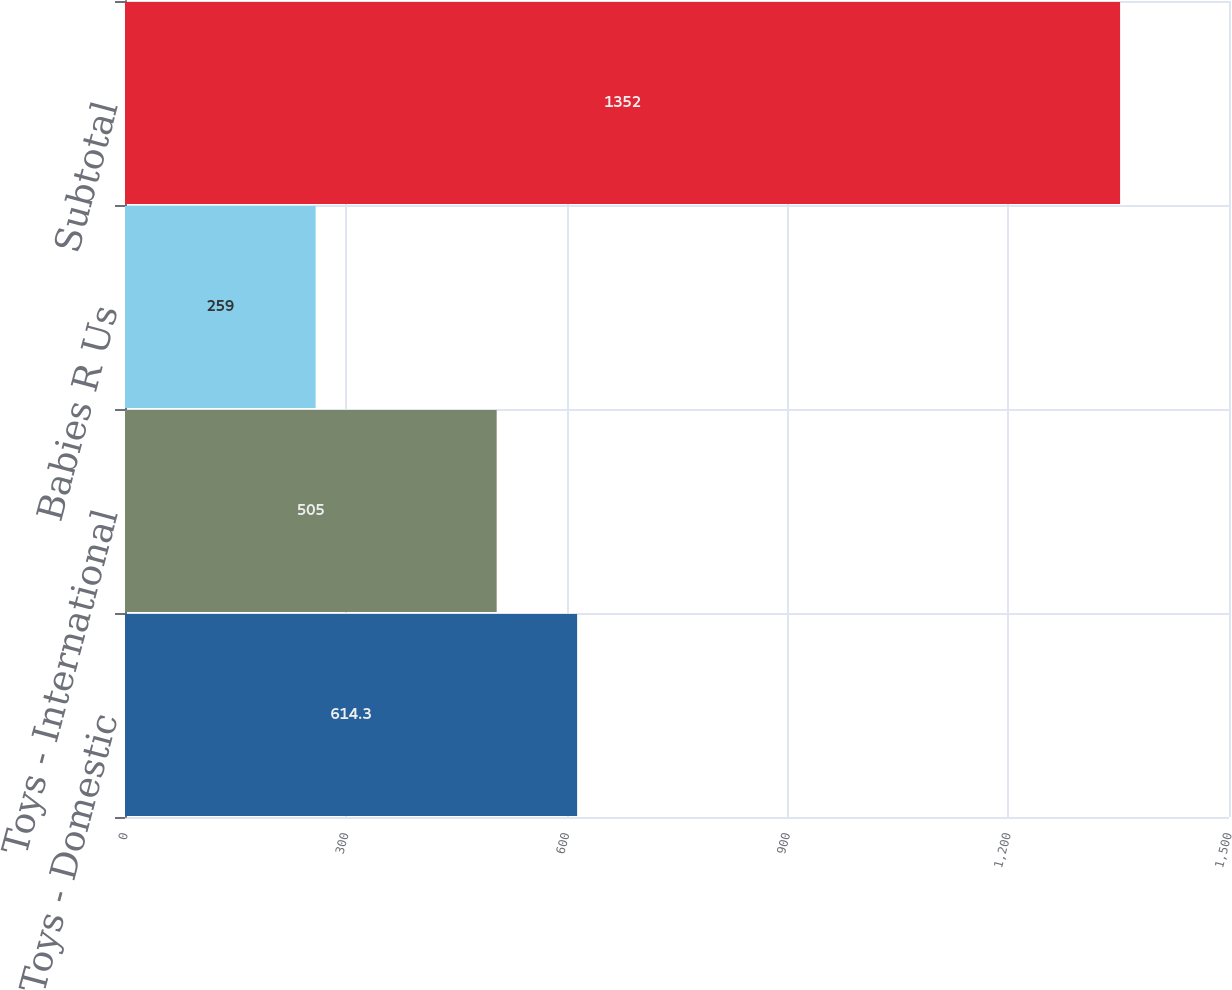Convert chart to OTSL. <chart><loc_0><loc_0><loc_500><loc_500><bar_chart><fcel>Toys - Domestic<fcel>Toys - International<fcel>Babies R Us<fcel>Subtotal<nl><fcel>614.3<fcel>505<fcel>259<fcel>1352<nl></chart> 